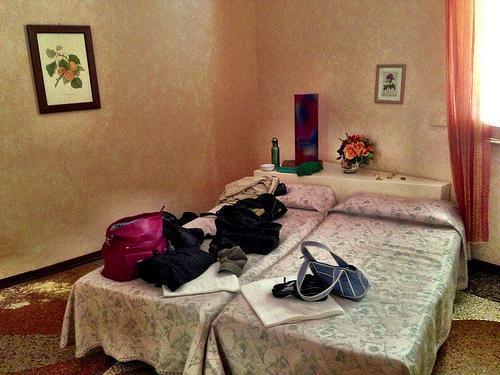How many beds are pictured?
Give a very brief answer. 2. How many people are laying on the bed?
Give a very brief answer. 0. How many people are sitting on the floor?
Give a very brief answer. 0. How many pictures are on the walls?
Give a very brief answer. 2. 